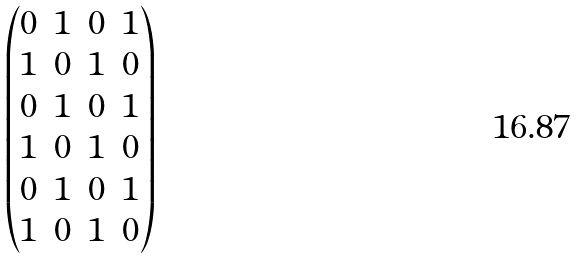Convert formula to latex. <formula><loc_0><loc_0><loc_500><loc_500>\begin{pmatrix} 0 & 1 & 0 & 1 \\ 1 & 0 & 1 & 0 \\ 0 & 1 & 0 & 1 \\ 1 & 0 & 1 & 0 \\ 0 & 1 & 0 & 1 \\ 1 & 0 & 1 & 0 \end{pmatrix}</formula> 